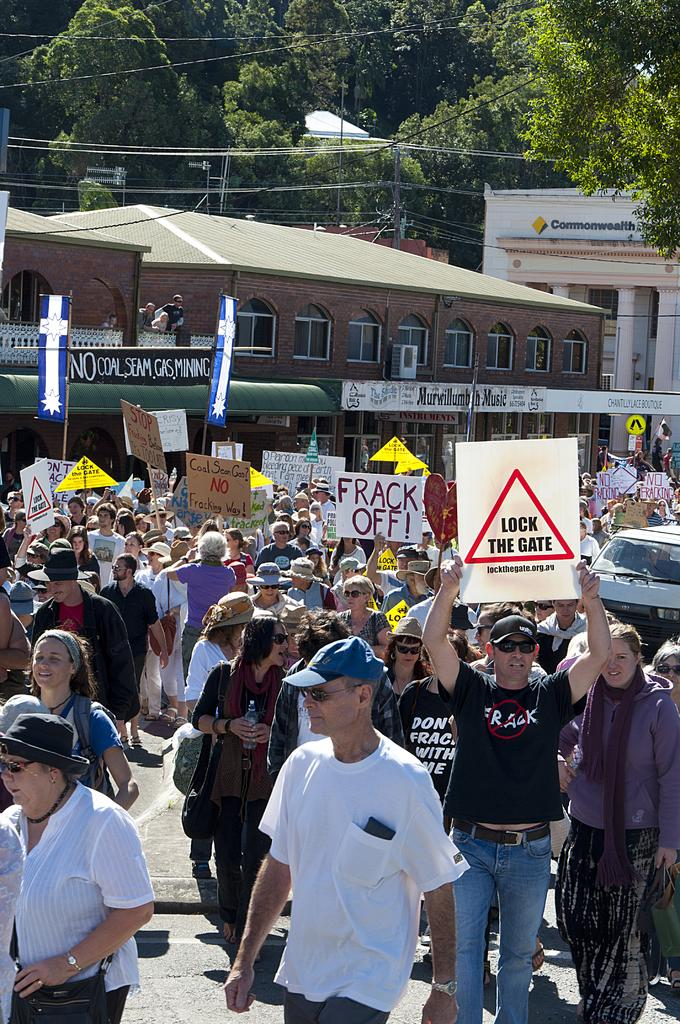What are the people in the image doing? The people in the image are standing on the road and holding pluck cards in their hands. What can be seen in the background of the image? There are buildings and trees in the background. What type of wine is being served at the table in the image? There is no table or wine present in the image; it features people standing on the road holding pluck cards. 